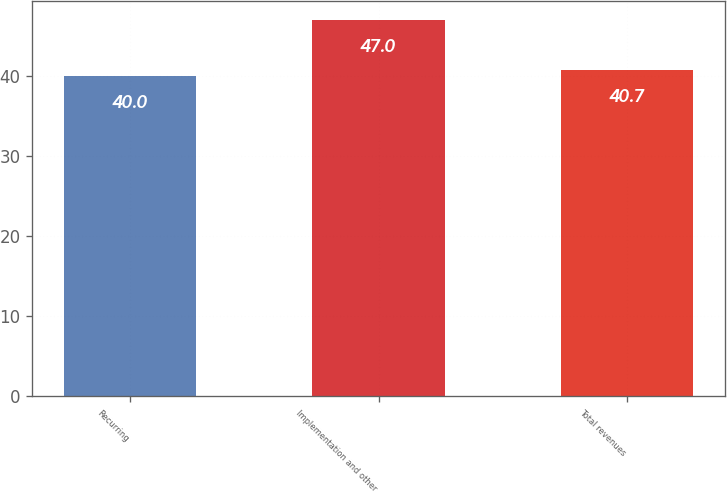<chart> <loc_0><loc_0><loc_500><loc_500><bar_chart><fcel>Recurring<fcel>Implementation and other<fcel>Total revenues<nl><fcel>40<fcel>47<fcel>40.7<nl></chart> 